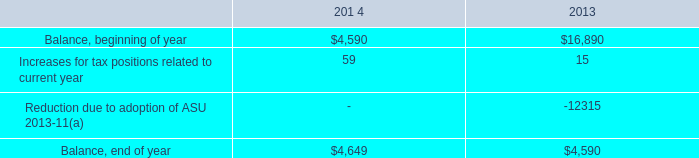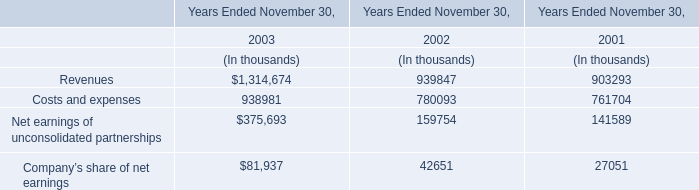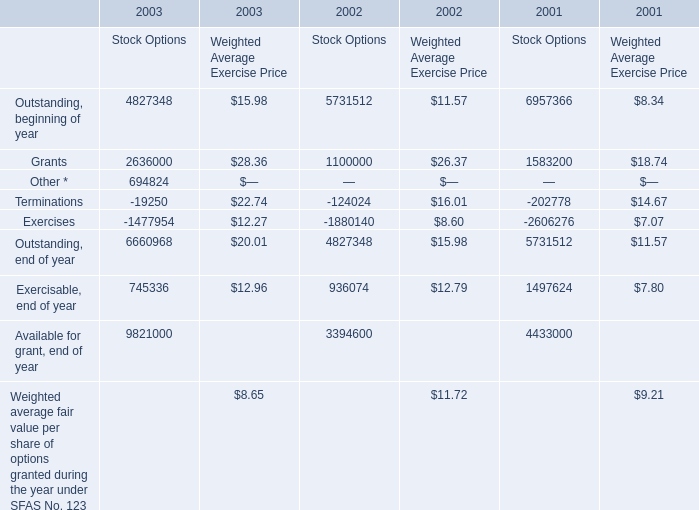How many years does Outstanding, beginning of year stay higher than Outstanding, end of year, for Stock Options? 
Answer: 2. 